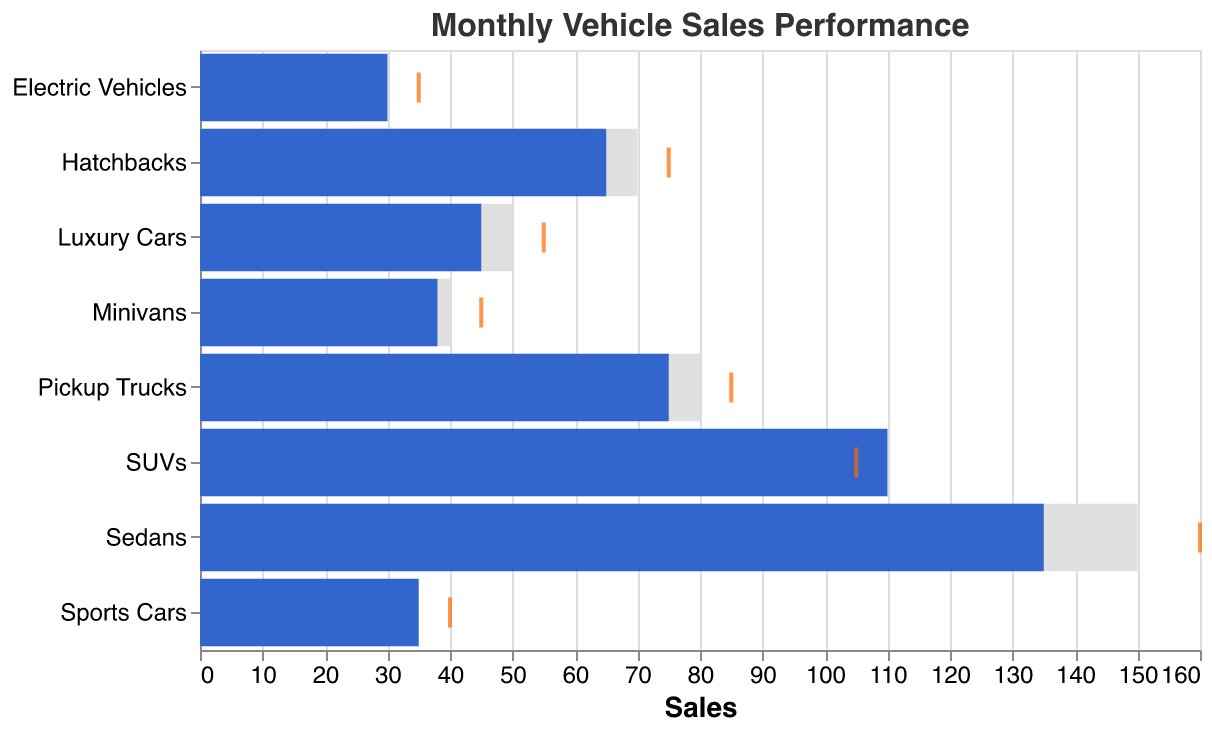What's the highest sales target among all vehicle categories? The "Sales Target" axis shows different target values for each vehicle category, and the highest value among them is for Sedans at 150.
Answer: 150 Which vehicle category exceeded its sales target the most? By comparing the Actual and Target bars, SUVs exceeded their sales target by 10.
Answer: SUVs What are the actual sales for Minivans and how do they compare to the benchmark? The Actual Sales bar for Minivans is 38, which is below the Benchmark tick at 45.
Answer: 38, below benchmark For which vehicle category is the sales target equal to the actual sales? None of the categories show bars where the Target and Actual sales precisely match.
Answer: None Which vehicle categories have actual sales below their target? Sedans, Luxury Cars, Pickup Trucks, Hatchbacks, and Minivans have Actual Sales bars that fall short of their respective Target bars.
Answer: Sedans, Luxury Cars, Pickup Trucks, Hatchbacks, Minivans How much more did SUVs achieve compared to their benchmark? SUVs have actual sales of 110, which is 5 more than the benchmark of 105.
Answer: 5 Which vehicle category had the smallest difference between target and actual sales? For Luxury Cars, the difference between Target (50) and Actual (45) is 5, which is the smallest in the chart.
Answer: Luxury Cars What is the overall sales target sum for all vehicle categories? Sum the Target values for all categories: 150 + 100 + 50 + 30 + 80 + 70 + 40 + 25 = 545.
Answer: 545 Which category's actual sales came closest to its benchmark? SUV's Actual Sales at 110 are closest to the Benchmark of 105, with a difference of 5.
Answer: SUVs By how much did Electric Vehicles exceed their sales target? The Actual Sales for Electric Vehicles are 30, which exceeds the Target of 25 by 5.
Answer: 5 